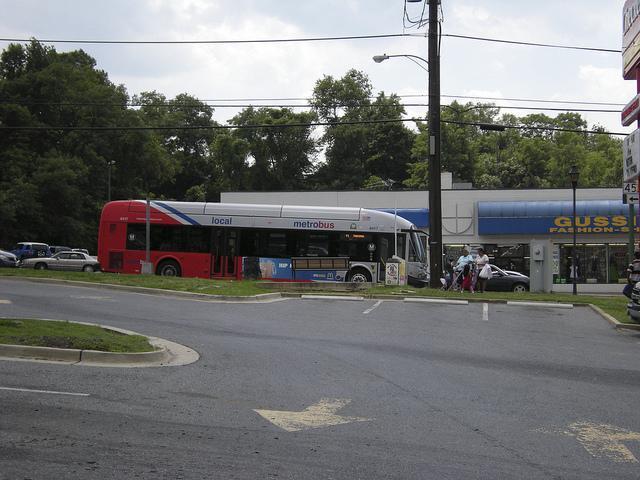How many people are wearing an orange shirt?
Give a very brief answer. 0. 